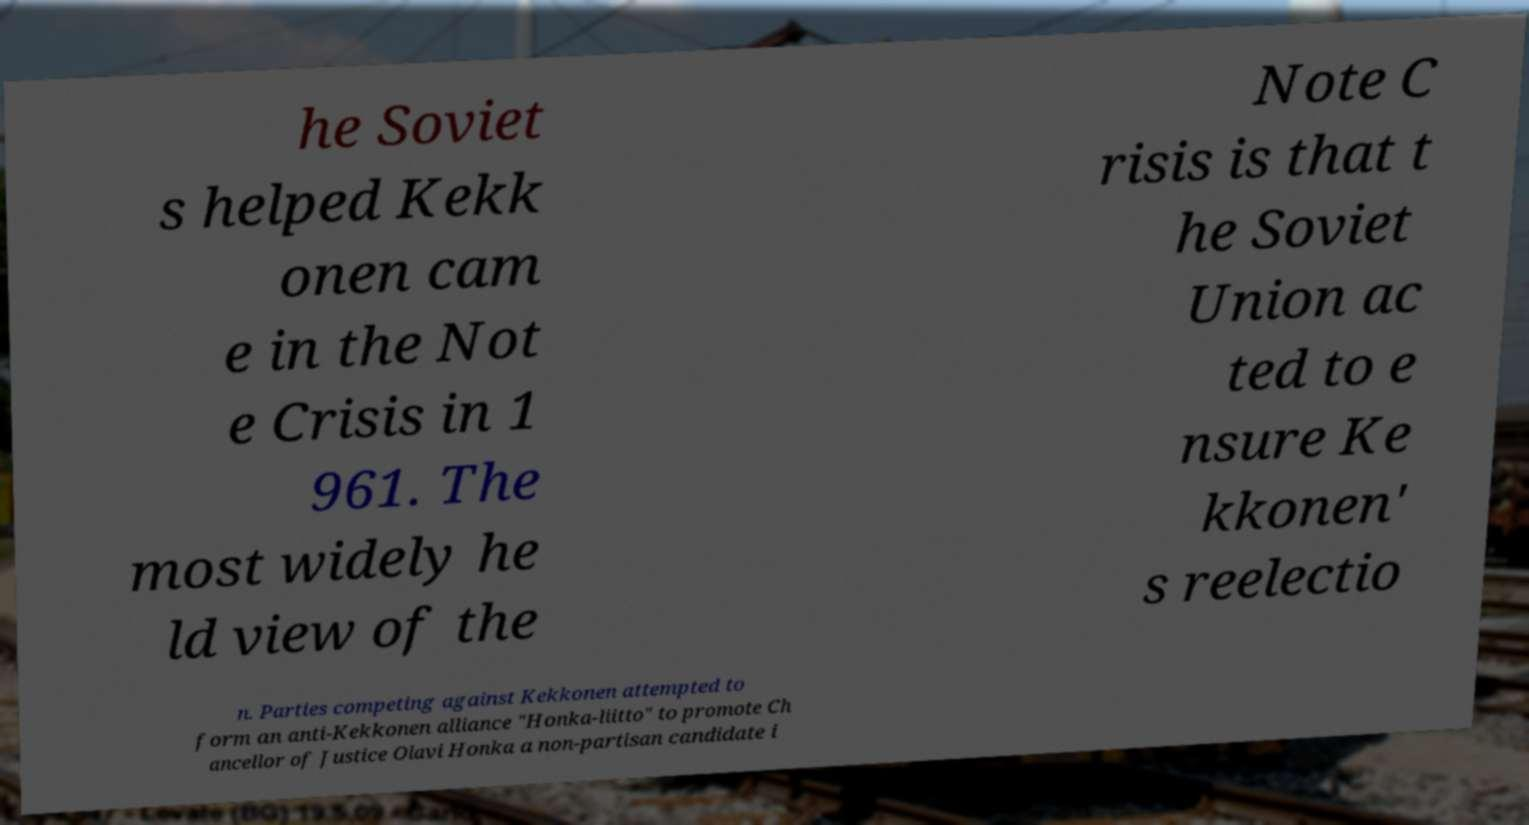Could you extract and type out the text from this image? he Soviet s helped Kekk onen cam e in the Not e Crisis in 1 961. The most widely he ld view of the Note C risis is that t he Soviet Union ac ted to e nsure Ke kkonen' s reelectio n. Parties competing against Kekkonen attempted to form an anti-Kekkonen alliance "Honka-liitto" to promote Ch ancellor of Justice Olavi Honka a non-partisan candidate i 